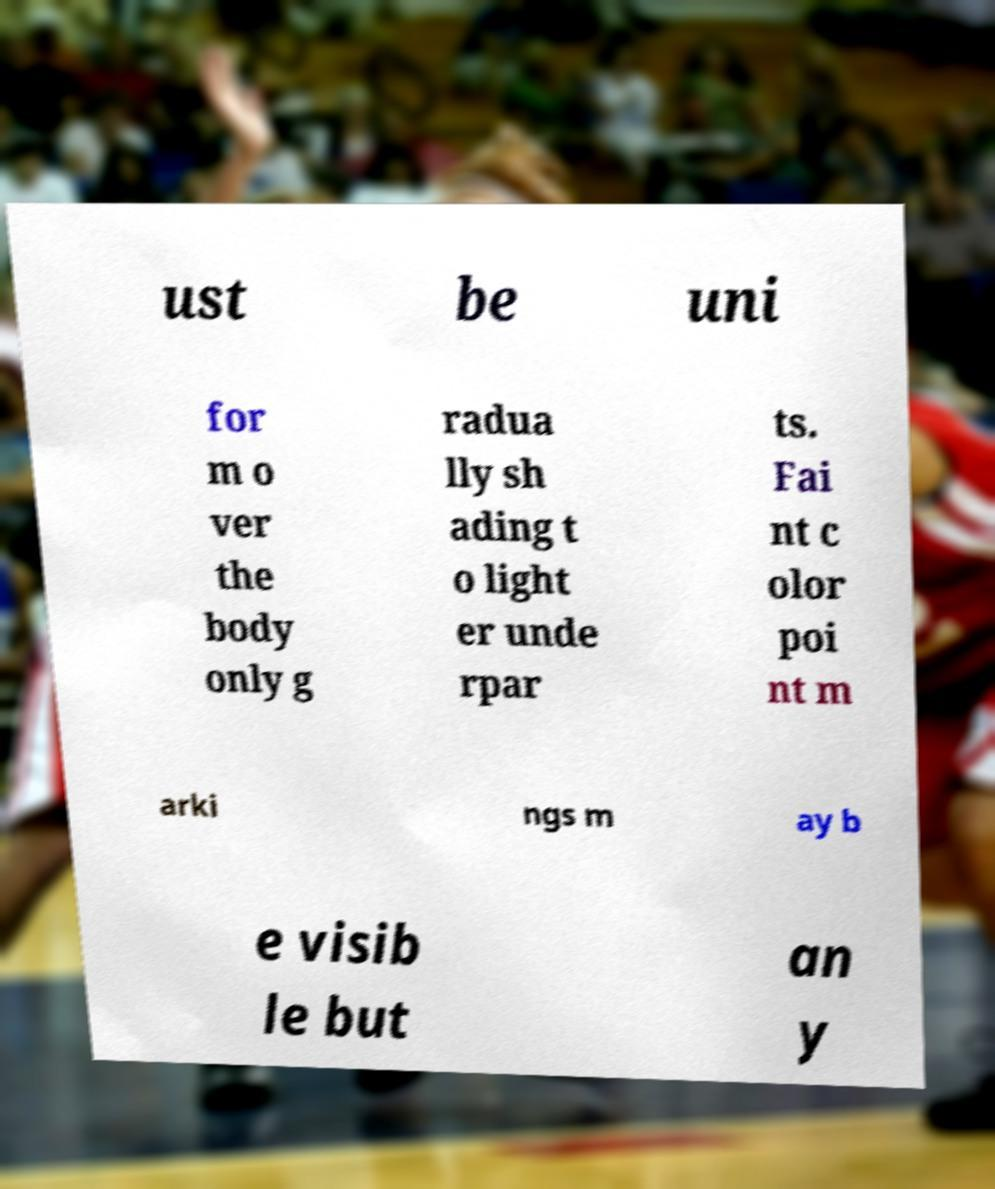Can you read and provide the text displayed in the image?This photo seems to have some interesting text. Can you extract and type it out for me? ust be uni for m o ver the body only g radua lly sh ading t o light er unde rpar ts. Fai nt c olor poi nt m arki ngs m ay b e visib le but an y 